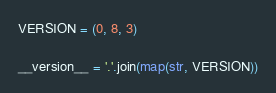Convert code to text. <code><loc_0><loc_0><loc_500><loc_500><_Python_>VERSION = (0, 8, 3)

__version__ = '.'.join(map(str, VERSION))
</code> 